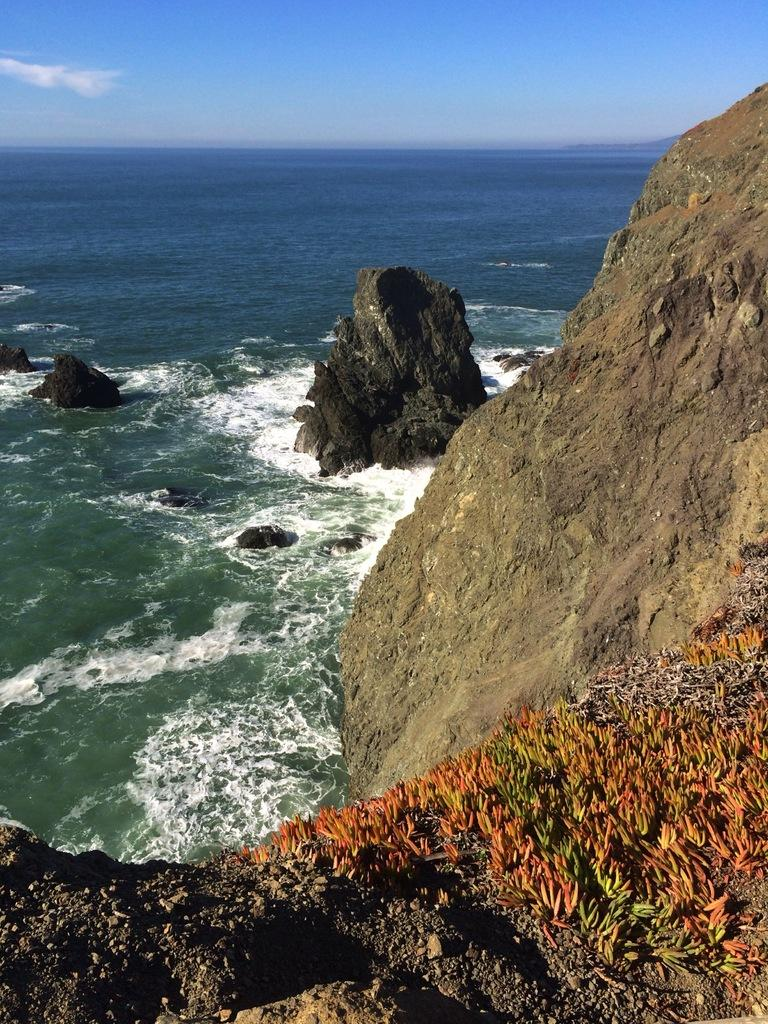What type of vegetation can be seen on the right side of the image? There are rocks with small plants on the right side of the image. What else can be seen in the water besides rocks? The facts do not mention anything else in the water besides rocks. What is visible at the top of the image? The sky is visible at the top of the image. What type of society can be seen in the image? There is no society present in the image; it features rocks, small plants, water, and rocks in the water. What authority figure is depicted in the image? There is no authority figure present in the image. 